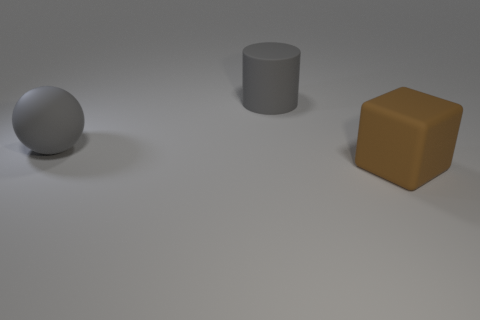There is a cylinder that is the same color as the large rubber sphere; what material is it?
Ensure brevity in your answer.  Rubber. There is a big object that is behind the large ball; what is its color?
Offer a terse response. Gray. There is a large brown cube in front of the large matte cylinder; are there any large brown objects behind it?
Your answer should be compact. No. What number of things are matte things that are in front of the rubber sphere or small brown matte cylinders?
Your answer should be very brief. 1. Are there any other things that have the same size as the gray cylinder?
Your answer should be very brief. Yes. What material is the large object behind the large gray object on the left side of the large cylinder?
Ensure brevity in your answer.  Rubber. Are there an equal number of large gray things in front of the large gray cylinder and blocks behind the big matte block?
Make the answer very short. No. What number of things are either large things that are left of the large brown matte cube or matte objects that are left of the big brown cube?
Your answer should be compact. 2. The object that is on the left side of the brown thing and to the right of the big rubber sphere is made of what material?
Offer a terse response. Rubber. How big is the gray rubber object that is in front of the gray matte object that is behind the big gray rubber thing in front of the matte cylinder?
Ensure brevity in your answer.  Large. 